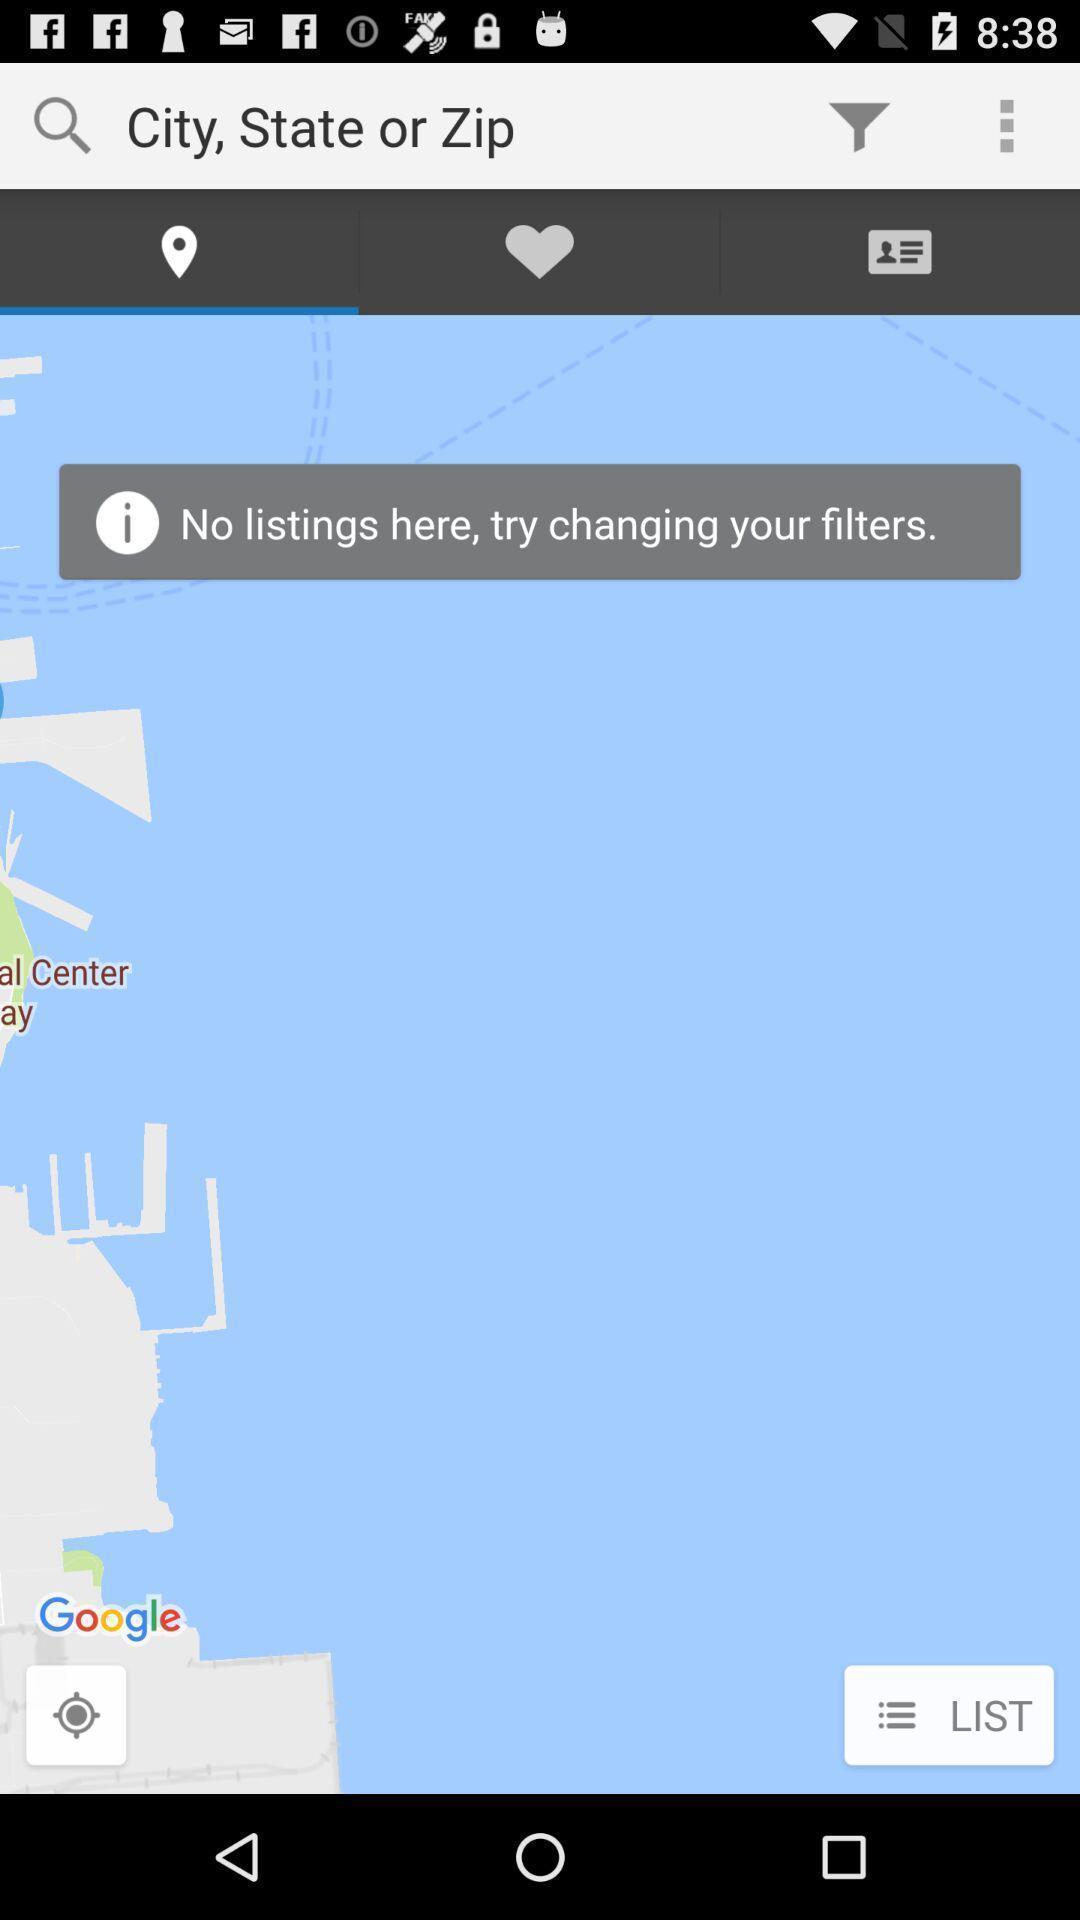Explain the elements present in this screenshot. Search bar to search for cities and states in app. 